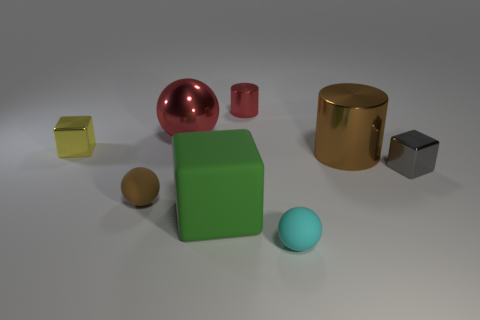Is the color of the big sphere the same as the tiny cylinder?
Provide a succinct answer. Yes. How many large blocks are made of the same material as the tiny brown object?
Provide a short and direct response. 1. How many big matte objects are there?
Provide a short and direct response. 1. There is a metallic cylinder that is on the left side of the brown cylinder; is it the same color as the large thing behind the yellow shiny block?
Offer a very short reply. Yes. There is a cyan rubber sphere; what number of brown matte balls are to the left of it?
Your response must be concise. 1. There is a tiny ball that is the same color as the large shiny cylinder; what material is it?
Your answer should be compact. Rubber. Is there a metallic thing of the same shape as the green rubber thing?
Give a very brief answer. Yes. Does the tiny object behind the small yellow block have the same material as the sphere behind the tiny yellow metal object?
Ensure brevity in your answer.  Yes. There is a cube in front of the cube on the right side of the cylinder left of the cyan matte ball; what size is it?
Provide a succinct answer. Large. There is a brown thing that is the same size as the red metal sphere; what is its material?
Your answer should be compact. Metal. 